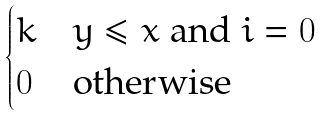<formula> <loc_0><loc_0><loc_500><loc_500>\begin{cases} k & \text {$y \leq x$ and $i=0$} \\ 0 & \text {otherwise} \end{cases}</formula> 